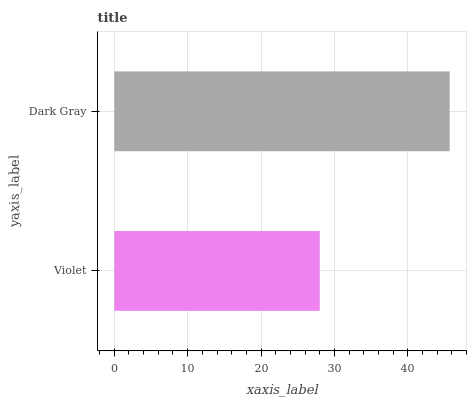Is Violet the minimum?
Answer yes or no. Yes. Is Dark Gray the maximum?
Answer yes or no. Yes. Is Dark Gray the minimum?
Answer yes or no. No. Is Dark Gray greater than Violet?
Answer yes or no. Yes. Is Violet less than Dark Gray?
Answer yes or no. Yes. Is Violet greater than Dark Gray?
Answer yes or no. No. Is Dark Gray less than Violet?
Answer yes or no. No. Is Dark Gray the high median?
Answer yes or no. Yes. Is Violet the low median?
Answer yes or no. Yes. Is Violet the high median?
Answer yes or no. No. Is Dark Gray the low median?
Answer yes or no. No. 